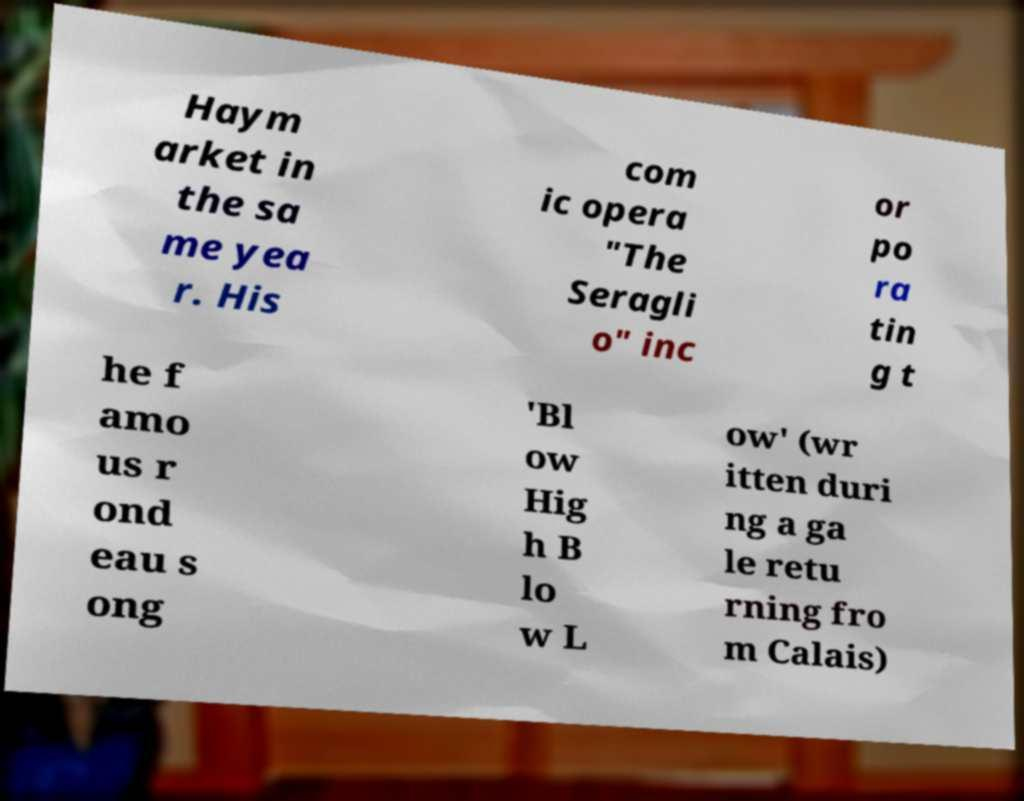Could you assist in decoding the text presented in this image and type it out clearly? Haym arket in the sa me yea r. His com ic opera "The Seragli o" inc or po ra tin g t he f amo us r ond eau s ong 'Bl ow Hig h B lo w L ow' (wr itten duri ng a ga le retu rning fro m Calais) 